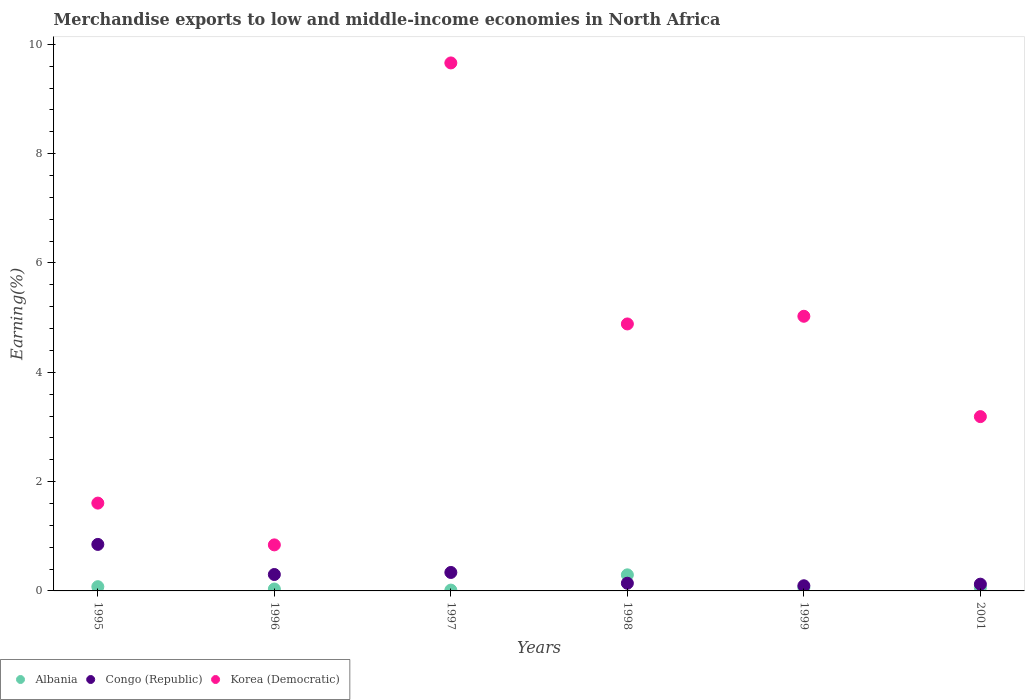How many different coloured dotlines are there?
Offer a terse response. 3. Is the number of dotlines equal to the number of legend labels?
Offer a terse response. Yes. What is the percentage of amount earned from merchandise exports in Congo (Republic) in 1997?
Your response must be concise. 0.34. Across all years, what is the maximum percentage of amount earned from merchandise exports in Korea (Democratic)?
Give a very brief answer. 9.66. Across all years, what is the minimum percentage of amount earned from merchandise exports in Korea (Democratic)?
Your response must be concise. 0.84. In which year was the percentage of amount earned from merchandise exports in Korea (Democratic) maximum?
Make the answer very short. 1997. In which year was the percentage of amount earned from merchandise exports in Congo (Republic) minimum?
Your answer should be compact. 1999. What is the total percentage of amount earned from merchandise exports in Korea (Democratic) in the graph?
Your response must be concise. 25.21. What is the difference between the percentage of amount earned from merchandise exports in Albania in 1996 and that in 1997?
Offer a terse response. 0.02. What is the difference between the percentage of amount earned from merchandise exports in Korea (Democratic) in 1995 and the percentage of amount earned from merchandise exports in Congo (Republic) in 1996?
Give a very brief answer. 1.31. What is the average percentage of amount earned from merchandise exports in Albania per year?
Your response must be concise. 0.09. In the year 1999, what is the difference between the percentage of amount earned from merchandise exports in Korea (Democratic) and percentage of amount earned from merchandise exports in Albania?
Offer a terse response. 4.97. What is the ratio of the percentage of amount earned from merchandise exports in Congo (Republic) in 1996 to that in 1997?
Your response must be concise. 0.89. Is the percentage of amount earned from merchandise exports in Korea (Democratic) in 1998 less than that in 2001?
Provide a short and direct response. No. Is the difference between the percentage of amount earned from merchandise exports in Korea (Democratic) in 1997 and 1999 greater than the difference between the percentage of amount earned from merchandise exports in Albania in 1997 and 1999?
Offer a very short reply. Yes. What is the difference between the highest and the second highest percentage of amount earned from merchandise exports in Albania?
Keep it short and to the point. 0.22. What is the difference between the highest and the lowest percentage of amount earned from merchandise exports in Congo (Republic)?
Make the answer very short. 0.76. Is it the case that in every year, the sum of the percentage of amount earned from merchandise exports in Korea (Democratic) and percentage of amount earned from merchandise exports in Albania  is greater than the percentage of amount earned from merchandise exports in Congo (Republic)?
Your answer should be very brief. Yes. Does the percentage of amount earned from merchandise exports in Albania monotonically increase over the years?
Provide a succinct answer. No. How many years are there in the graph?
Your answer should be compact. 6. What is the difference between two consecutive major ticks on the Y-axis?
Keep it short and to the point. 2. Are the values on the major ticks of Y-axis written in scientific E-notation?
Your answer should be very brief. No. Does the graph contain any zero values?
Ensure brevity in your answer.  No. Does the graph contain grids?
Keep it short and to the point. No. Where does the legend appear in the graph?
Provide a short and direct response. Bottom left. How many legend labels are there?
Make the answer very short. 3. What is the title of the graph?
Provide a short and direct response. Merchandise exports to low and middle-income economies in North Africa. What is the label or title of the Y-axis?
Ensure brevity in your answer.  Earning(%). What is the Earning(%) of Albania in 1995?
Ensure brevity in your answer.  0.08. What is the Earning(%) of Congo (Republic) in 1995?
Give a very brief answer. 0.85. What is the Earning(%) of Korea (Democratic) in 1995?
Provide a succinct answer. 1.61. What is the Earning(%) of Albania in 1996?
Provide a succinct answer. 0.03. What is the Earning(%) in Congo (Republic) in 1996?
Provide a succinct answer. 0.3. What is the Earning(%) of Korea (Democratic) in 1996?
Make the answer very short. 0.84. What is the Earning(%) of Albania in 1997?
Provide a succinct answer. 0.01. What is the Earning(%) in Congo (Republic) in 1997?
Your answer should be compact. 0.34. What is the Earning(%) in Korea (Democratic) in 1997?
Your response must be concise. 9.66. What is the Earning(%) of Albania in 1998?
Your answer should be compact. 0.29. What is the Earning(%) in Congo (Republic) in 1998?
Keep it short and to the point. 0.14. What is the Earning(%) of Korea (Democratic) in 1998?
Ensure brevity in your answer.  4.88. What is the Earning(%) of Albania in 1999?
Make the answer very short. 0.06. What is the Earning(%) in Congo (Republic) in 1999?
Your answer should be very brief. 0.09. What is the Earning(%) in Korea (Democratic) in 1999?
Provide a short and direct response. 5.02. What is the Earning(%) of Albania in 2001?
Your answer should be compact. 0.06. What is the Earning(%) in Congo (Republic) in 2001?
Make the answer very short. 0.12. What is the Earning(%) of Korea (Democratic) in 2001?
Your answer should be compact. 3.19. Across all years, what is the maximum Earning(%) of Albania?
Keep it short and to the point. 0.29. Across all years, what is the maximum Earning(%) in Congo (Republic)?
Give a very brief answer. 0.85. Across all years, what is the maximum Earning(%) in Korea (Democratic)?
Give a very brief answer. 9.66. Across all years, what is the minimum Earning(%) of Albania?
Provide a short and direct response. 0.01. Across all years, what is the minimum Earning(%) of Congo (Republic)?
Keep it short and to the point. 0.09. Across all years, what is the minimum Earning(%) of Korea (Democratic)?
Offer a terse response. 0.84. What is the total Earning(%) in Albania in the graph?
Keep it short and to the point. 0.54. What is the total Earning(%) in Congo (Republic) in the graph?
Your answer should be compact. 1.85. What is the total Earning(%) in Korea (Democratic) in the graph?
Give a very brief answer. 25.21. What is the difference between the Earning(%) in Albania in 1995 and that in 1996?
Offer a very short reply. 0.04. What is the difference between the Earning(%) in Congo (Republic) in 1995 and that in 1996?
Offer a terse response. 0.55. What is the difference between the Earning(%) in Korea (Democratic) in 1995 and that in 1996?
Provide a short and direct response. 0.76. What is the difference between the Earning(%) of Albania in 1995 and that in 1997?
Give a very brief answer. 0.06. What is the difference between the Earning(%) of Congo (Republic) in 1995 and that in 1997?
Make the answer very short. 0.51. What is the difference between the Earning(%) in Korea (Democratic) in 1995 and that in 1997?
Your response must be concise. -8.05. What is the difference between the Earning(%) in Albania in 1995 and that in 1998?
Your response must be concise. -0.22. What is the difference between the Earning(%) of Congo (Republic) in 1995 and that in 1998?
Make the answer very short. 0.71. What is the difference between the Earning(%) in Korea (Democratic) in 1995 and that in 1998?
Your answer should be compact. -3.28. What is the difference between the Earning(%) of Albania in 1995 and that in 1999?
Your answer should be very brief. 0.02. What is the difference between the Earning(%) in Congo (Republic) in 1995 and that in 1999?
Provide a succinct answer. 0.76. What is the difference between the Earning(%) in Korea (Democratic) in 1995 and that in 1999?
Give a very brief answer. -3.42. What is the difference between the Earning(%) in Albania in 1995 and that in 2001?
Ensure brevity in your answer.  0.02. What is the difference between the Earning(%) of Congo (Republic) in 1995 and that in 2001?
Provide a succinct answer. 0.73. What is the difference between the Earning(%) of Korea (Democratic) in 1995 and that in 2001?
Your response must be concise. -1.58. What is the difference between the Earning(%) of Congo (Republic) in 1996 and that in 1997?
Offer a terse response. -0.04. What is the difference between the Earning(%) of Korea (Democratic) in 1996 and that in 1997?
Provide a short and direct response. -8.82. What is the difference between the Earning(%) in Albania in 1996 and that in 1998?
Ensure brevity in your answer.  -0.26. What is the difference between the Earning(%) in Congo (Republic) in 1996 and that in 1998?
Offer a terse response. 0.16. What is the difference between the Earning(%) in Korea (Democratic) in 1996 and that in 1998?
Your answer should be very brief. -4.04. What is the difference between the Earning(%) of Albania in 1996 and that in 1999?
Offer a terse response. -0.02. What is the difference between the Earning(%) in Congo (Republic) in 1996 and that in 1999?
Make the answer very short. 0.21. What is the difference between the Earning(%) of Korea (Democratic) in 1996 and that in 1999?
Provide a short and direct response. -4.18. What is the difference between the Earning(%) of Albania in 1996 and that in 2001?
Provide a succinct answer. -0.03. What is the difference between the Earning(%) of Congo (Republic) in 1996 and that in 2001?
Offer a terse response. 0.18. What is the difference between the Earning(%) of Korea (Democratic) in 1996 and that in 2001?
Provide a short and direct response. -2.35. What is the difference between the Earning(%) in Albania in 1997 and that in 1998?
Provide a short and direct response. -0.28. What is the difference between the Earning(%) of Congo (Republic) in 1997 and that in 1998?
Provide a succinct answer. 0.2. What is the difference between the Earning(%) in Korea (Democratic) in 1997 and that in 1998?
Provide a short and direct response. 4.78. What is the difference between the Earning(%) of Albania in 1997 and that in 1999?
Your answer should be compact. -0.04. What is the difference between the Earning(%) in Congo (Republic) in 1997 and that in 1999?
Your answer should be compact. 0.24. What is the difference between the Earning(%) in Korea (Democratic) in 1997 and that in 1999?
Provide a short and direct response. 4.63. What is the difference between the Earning(%) of Albania in 1997 and that in 2001?
Provide a succinct answer. -0.05. What is the difference between the Earning(%) of Congo (Republic) in 1997 and that in 2001?
Give a very brief answer. 0.21. What is the difference between the Earning(%) in Korea (Democratic) in 1997 and that in 2001?
Give a very brief answer. 6.47. What is the difference between the Earning(%) in Albania in 1998 and that in 1999?
Your answer should be very brief. 0.24. What is the difference between the Earning(%) in Congo (Republic) in 1998 and that in 1999?
Provide a short and direct response. 0.05. What is the difference between the Earning(%) in Korea (Democratic) in 1998 and that in 1999?
Your answer should be compact. -0.14. What is the difference between the Earning(%) in Albania in 1998 and that in 2001?
Ensure brevity in your answer.  0.23. What is the difference between the Earning(%) of Congo (Republic) in 1998 and that in 2001?
Your response must be concise. 0.02. What is the difference between the Earning(%) in Korea (Democratic) in 1998 and that in 2001?
Your answer should be very brief. 1.7. What is the difference between the Earning(%) in Albania in 1999 and that in 2001?
Your response must be concise. -0. What is the difference between the Earning(%) in Congo (Republic) in 1999 and that in 2001?
Your response must be concise. -0.03. What is the difference between the Earning(%) of Korea (Democratic) in 1999 and that in 2001?
Provide a succinct answer. 1.84. What is the difference between the Earning(%) of Albania in 1995 and the Earning(%) of Congo (Republic) in 1996?
Provide a succinct answer. -0.22. What is the difference between the Earning(%) of Albania in 1995 and the Earning(%) of Korea (Democratic) in 1996?
Offer a very short reply. -0.76. What is the difference between the Earning(%) of Congo (Republic) in 1995 and the Earning(%) of Korea (Democratic) in 1996?
Offer a terse response. 0.01. What is the difference between the Earning(%) of Albania in 1995 and the Earning(%) of Congo (Republic) in 1997?
Provide a short and direct response. -0.26. What is the difference between the Earning(%) in Albania in 1995 and the Earning(%) in Korea (Democratic) in 1997?
Keep it short and to the point. -9.58. What is the difference between the Earning(%) in Congo (Republic) in 1995 and the Earning(%) in Korea (Democratic) in 1997?
Your answer should be compact. -8.81. What is the difference between the Earning(%) of Albania in 1995 and the Earning(%) of Congo (Republic) in 1998?
Provide a succinct answer. -0.06. What is the difference between the Earning(%) in Albania in 1995 and the Earning(%) in Korea (Democratic) in 1998?
Make the answer very short. -4.81. What is the difference between the Earning(%) of Congo (Republic) in 1995 and the Earning(%) of Korea (Democratic) in 1998?
Offer a very short reply. -4.03. What is the difference between the Earning(%) in Albania in 1995 and the Earning(%) in Congo (Republic) in 1999?
Offer a very short reply. -0.02. What is the difference between the Earning(%) in Albania in 1995 and the Earning(%) in Korea (Democratic) in 1999?
Make the answer very short. -4.95. What is the difference between the Earning(%) of Congo (Republic) in 1995 and the Earning(%) of Korea (Democratic) in 1999?
Make the answer very short. -4.17. What is the difference between the Earning(%) in Albania in 1995 and the Earning(%) in Congo (Republic) in 2001?
Give a very brief answer. -0.05. What is the difference between the Earning(%) in Albania in 1995 and the Earning(%) in Korea (Democratic) in 2001?
Provide a short and direct response. -3.11. What is the difference between the Earning(%) in Congo (Republic) in 1995 and the Earning(%) in Korea (Democratic) in 2001?
Provide a short and direct response. -2.34. What is the difference between the Earning(%) in Albania in 1996 and the Earning(%) in Congo (Republic) in 1997?
Offer a terse response. -0.3. What is the difference between the Earning(%) of Albania in 1996 and the Earning(%) of Korea (Democratic) in 1997?
Keep it short and to the point. -9.62. What is the difference between the Earning(%) of Congo (Republic) in 1996 and the Earning(%) of Korea (Democratic) in 1997?
Offer a very short reply. -9.36. What is the difference between the Earning(%) of Albania in 1996 and the Earning(%) of Congo (Republic) in 1998?
Give a very brief answer. -0.11. What is the difference between the Earning(%) in Albania in 1996 and the Earning(%) in Korea (Democratic) in 1998?
Your answer should be compact. -4.85. What is the difference between the Earning(%) of Congo (Republic) in 1996 and the Earning(%) of Korea (Democratic) in 1998?
Ensure brevity in your answer.  -4.58. What is the difference between the Earning(%) of Albania in 1996 and the Earning(%) of Congo (Republic) in 1999?
Keep it short and to the point. -0.06. What is the difference between the Earning(%) of Albania in 1996 and the Earning(%) of Korea (Democratic) in 1999?
Offer a very short reply. -4.99. What is the difference between the Earning(%) in Congo (Republic) in 1996 and the Earning(%) in Korea (Democratic) in 1999?
Your response must be concise. -4.72. What is the difference between the Earning(%) in Albania in 1996 and the Earning(%) in Congo (Republic) in 2001?
Offer a very short reply. -0.09. What is the difference between the Earning(%) of Albania in 1996 and the Earning(%) of Korea (Democratic) in 2001?
Offer a terse response. -3.15. What is the difference between the Earning(%) of Congo (Republic) in 1996 and the Earning(%) of Korea (Democratic) in 2001?
Ensure brevity in your answer.  -2.89. What is the difference between the Earning(%) in Albania in 1997 and the Earning(%) in Congo (Republic) in 1998?
Keep it short and to the point. -0.13. What is the difference between the Earning(%) of Albania in 1997 and the Earning(%) of Korea (Democratic) in 1998?
Provide a short and direct response. -4.87. What is the difference between the Earning(%) of Congo (Republic) in 1997 and the Earning(%) of Korea (Democratic) in 1998?
Give a very brief answer. -4.55. What is the difference between the Earning(%) in Albania in 1997 and the Earning(%) in Congo (Republic) in 1999?
Make the answer very short. -0.08. What is the difference between the Earning(%) of Albania in 1997 and the Earning(%) of Korea (Democratic) in 1999?
Provide a succinct answer. -5.01. What is the difference between the Earning(%) in Congo (Republic) in 1997 and the Earning(%) in Korea (Democratic) in 1999?
Provide a short and direct response. -4.69. What is the difference between the Earning(%) of Albania in 1997 and the Earning(%) of Congo (Republic) in 2001?
Your response must be concise. -0.11. What is the difference between the Earning(%) in Albania in 1997 and the Earning(%) in Korea (Democratic) in 2001?
Offer a terse response. -3.17. What is the difference between the Earning(%) in Congo (Republic) in 1997 and the Earning(%) in Korea (Democratic) in 2001?
Offer a terse response. -2.85. What is the difference between the Earning(%) in Albania in 1998 and the Earning(%) in Congo (Republic) in 1999?
Give a very brief answer. 0.2. What is the difference between the Earning(%) of Albania in 1998 and the Earning(%) of Korea (Democratic) in 1999?
Provide a succinct answer. -4.73. What is the difference between the Earning(%) in Congo (Republic) in 1998 and the Earning(%) in Korea (Democratic) in 1999?
Keep it short and to the point. -4.88. What is the difference between the Earning(%) of Albania in 1998 and the Earning(%) of Congo (Republic) in 2001?
Your response must be concise. 0.17. What is the difference between the Earning(%) of Albania in 1998 and the Earning(%) of Korea (Democratic) in 2001?
Offer a very short reply. -2.89. What is the difference between the Earning(%) of Congo (Republic) in 1998 and the Earning(%) of Korea (Democratic) in 2001?
Your answer should be very brief. -3.05. What is the difference between the Earning(%) in Albania in 1999 and the Earning(%) in Congo (Republic) in 2001?
Your answer should be very brief. -0.07. What is the difference between the Earning(%) of Albania in 1999 and the Earning(%) of Korea (Democratic) in 2001?
Keep it short and to the point. -3.13. What is the difference between the Earning(%) in Congo (Republic) in 1999 and the Earning(%) in Korea (Democratic) in 2001?
Your answer should be compact. -3.09. What is the average Earning(%) in Albania per year?
Keep it short and to the point. 0.09. What is the average Earning(%) in Congo (Republic) per year?
Keep it short and to the point. 0.31. What is the average Earning(%) in Korea (Democratic) per year?
Make the answer very short. 4.2. In the year 1995, what is the difference between the Earning(%) of Albania and Earning(%) of Congo (Republic)?
Provide a short and direct response. -0.77. In the year 1995, what is the difference between the Earning(%) in Albania and Earning(%) in Korea (Democratic)?
Keep it short and to the point. -1.53. In the year 1995, what is the difference between the Earning(%) in Congo (Republic) and Earning(%) in Korea (Democratic)?
Provide a short and direct response. -0.76. In the year 1996, what is the difference between the Earning(%) of Albania and Earning(%) of Congo (Republic)?
Your answer should be very brief. -0.27. In the year 1996, what is the difference between the Earning(%) of Albania and Earning(%) of Korea (Democratic)?
Keep it short and to the point. -0.81. In the year 1996, what is the difference between the Earning(%) in Congo (Republic) and Earning(%) in Korea (Democratic)?
Your answer should be compact. -0.54. In the year 1997, what is the difference between the Earning(%) of Albania and Earning(%) of Congo (Republic)?
Give a very brief answer. -0.32. In the year 1997, what is the difference between the Earning(%) of Albania and Earning(%) of Korea (Democratic)?
Your response must be concise. -9.64. In the year 1997, what is the difference between the Earning(%) in Congo (Republic) and Earning(%) in Korea (Democratic)?
Your answer should be compact. -9.32. In the year 1998, what is the difference between the Earning(%) of Albania and Earning(%) of Congo (Republic)?
Make the answer very short. 0.15. In the year 1998, what is the difference between the Earning(%) in Albania and Earning(%) in Korea (Democratic)?
Provide a short and direct response. -4.59. In the year 1998, what is the difference between the Earning(%) in Congo (Republic) and Earning(%) in Korea (Democratic)?
Provide a short and direct response. -4.74. In the year 1999, what is the difference between the Earning(%) of Albania and Earning(%) of Congo (Republic)?
Offer a very short reply. -0.04. In the year 1999, what is the difference between the Earning(%) of Albania and Earning(%) of Korea (Democratic)?
Keep it short and to the point. -4.97. In the year 1999, what is the difference between the Earning(%) in Congo (Republic) and Earning(%) in Korea (Democratic)?
Give a very brief answer. -4.93. In the year 2001, what is the difference between the Earning(%) of Albania and Earning(%) of Congo (Republic)?
Provide a short and direct response. -0.06. In the year 2001, what is the difference between the Earning(%) in Albania and Earning(%) in Korea (Democratic)?
Provide a succinct answer. -3.13. In the year 2001, what is the difference between the Earning(%) of Congo (Republic) and Earning(%) of Korea (Democratic)?
Make the answer very short. -3.07. What is the ratio of the Earning(%) of Albania in 1995 to that in 1996?
Offer a very short reply. 2.21. What is the ratio of the Earning(%) of Congo (Republic) in 1995 to that in 1996?
Offer a very short reply. 2.83. What is the ratio of the Earning(%) in Korea (Democratic) in 1995 to that in 1996?
Your answer should be very brief. 1.91. What is the ratio of the Earning(%) in Albania in 1995 to that in 1997?
Your answer should be compact. 5.18. What is the ratio of the Earning(%) of Congo (Republic) in 1995 to that in 1997?
Give a very brief answer. 2.52. What is the ratio of the Earning(%) in Korea (Democratic) in 1995 to that in 1997?
Provide a succinct answer. 0.17. What is the ratio of the Earning(%) in Albania in 1995 to that in 1998?
Your response must be concise. 0.26. What is the ratio of the Earning(%) of Congo (Republic) in 1995 to that in 1998?
Your answer should be compact. 6.05. What is the ratio of the Earning(%) of Korea (Democratic) in 1995 to that in 1998?
Provide a succinct answer. 0.33. What is the ratio of the Earning(%) of Albania in 1995 to that in 1999?
Ensure brevity in your answer.  1.34. What is the ratio of the Earning(%) in Congo (Republic) in 1995 to that in 1999?
Offer a terse response. 9.02. What is the ratio of the Earning(%) in Korea (Democratic) in 1995 to that in 1999?
Ensure brevity in your answer.  0.32. What is the ratio of the Earning(%) of Albania in 1995 to that in 2001?
Provide a short and direct response. 1.24. What is the ratio of the Earning(%) of Congo (Republic) in 1995 to that in 2001?
Keep it short and to the point. 6.88. What is the ratio of the Earning(%) of Korea (Democratic) in 1995 to that in 2001?
Provide a succinct answer. 0.5. What is the ratio of the Earning(%) in Albania in 1996 to that in 1997?
Provide a short and direct response. 2.34. What is the ratio of the Earning(%) in Congo (Republic) in 1996 to that in 1997?
Make the answer very short. 0.89. What is the ratio of the Earning(%) in Korea (Democratic) in 1996 to that in 1997?
Offer a terse response. 0.09. What is the ratio of the Earning(%) in Albania in 1996 to that in 1998?
Provide a short and direct response. 0.12. What is the ratio of the Earning(%) of Congo (Republic) in 1996 to that in 1998?
Keep it short and to the point. 2.13. What is the ratio of the Earning(%) of Korea (Democratic) in 1996 to that in 1998?
Provide a short and direct response. 0.17. What is the ratio of the Earning(%) of Albania in 1996 to that in 1999?
Offer a terse response. 0.6. What is the ratio of the Earning(%) of Congo (Republic) in 1996 to that in 1999?
Ensure brevity in your answer.  3.18. What is the ratio of the Earning(%) of Korea (Democratic) in 1996 to that in 1999?
Keep it short and to the point. 0.17. What is the ratio of the Earning(%) of Albania in 1996 to that in 2001?
Make the answer very short. 0.56. What is the ratio of the Earning(%) in Congo (Republic) in 1996 to that in 2001?
Your answer should be compact. 2.43. What is the ratio of the Earning(%) of Korea (Democratic) in 1996 to that in 2001?
Offer a very short reply. 0.26. What is the ratio of the Earning(%) of Albania in 1997 to that in 1998?
Give a very brief answer. 0.05. What is the ratio of the Earning(%) in Congo (Republic) in 1997 to that in 1998?
Offer a very short reply. 2.4. What is the ratio of the Earning(%) of Korea (Democratic) in 1997 to that in 1998?
Your answer should be compact. 1.98. What is the ratio of the Earning(%) of Albania in 1997 to that in 1999?
Your response must be concise. 0.26. What is the ratio of the Earning(%) in Congo (Republic) in 1997 to that in 1999?
Offer a very short reply. 3.58. What is the ratio of the Earning(%) in Korea (Democratic) in 1997 to that in 1999?
Ensure brevity in your answer.  1.92. What is the ratio of the Earning(%) in Albania in 1997 to that in 2001?
Provide a short and direct response. 0.24. What is the ratio of the Earning(%) in Congo (Republic) in 1997 to that in 2001?
Offer a terse response. 2.73. What is the ratio of the Earning(%) of Korea (Democratic) in 1997 to that in 2001?
Provide a succinct answer. 3.03. What is the ratio of the Earning(%) in Albania in 1998 to that in 1999?
Keep it short and to the point. 5.07. What is the ratio of the Earning(%) in Congo (Republic) in 1998 to that in 1999?
Offer a terse response. 1.49. What is the ratio of the Earning(%) of Albania in 1998 to that in 2001?
Offer a terse response. 4.71. What is the ratio of the Earning(%) of Congo (Republic) in 1998 to that in 2001?
Offer a very short reply. 1.14. What is the ratio of the Earning(%) of Korea (Democratic) in 1998 to that in 2001?
Give a very brief answer. 1.53. What is the ratio of the Earning(%) in Albania in 1999 to that in 2001?
Ensure brevity in your answer.  0.93. What is the ratio of the Earning(%) in Congo (Republic) in 1999 to that in 2001?
Ensure brevity in your answer.  0.76. What is the ratio of the Earning(%) in Korea (Democratic) in 1999 to that in 2001?
Offer a terse response. 1.58. What is the difference between the highest and the second highest Earning(%) in Albania?
Make the answer very short. 0.22. What is the difference between the highest and the second highest Earning(%) of Congo (Republic)?
Your answer should be compact. 0.51. What is the difference between the highest and the second highest Earning(%) of Korea (Democratic)?
Provide a short and direct response. 4.63. What is the difference between the highest and the lowest Earning(%) of Albania?
Your response must be concise. 0.28. What is the difference between the highest and the lowest Earning(%) in Congo (Republic)?
Provide a short and direct response. 0.76. What is the difference between the highest and the lowest Earning(%) in Korea (Democratic)?
Provide a succinct answer. 8.82. 